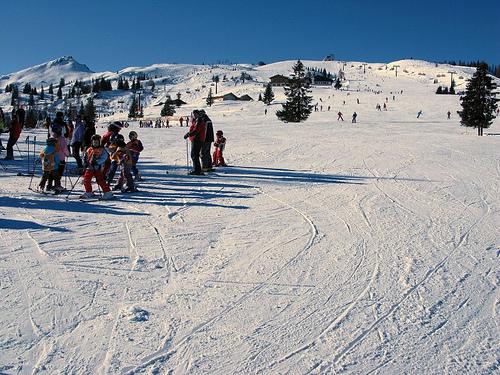What type of tree is shown?
Be succinct. Pine. Is there a lot of snow?
Answer briefly. Yes. Where in the picture are the people standing?
Concise answer only. Snow. Does the snow have tracks in it?
Keep it brief. Yes. Are the slopes crowded with people?
Quick response, please. Yes. Is the sky clear?
Concise answer only. Yes. 